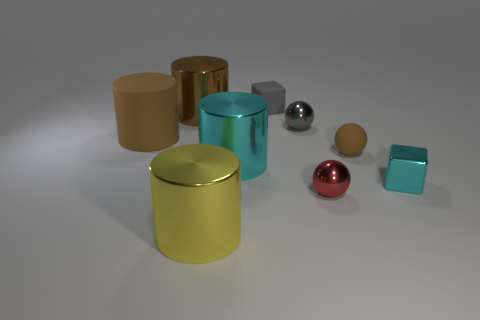What number of metal objects are either tiny purple cubes or large objects?
Ensure brevity in your answer.  3. Is the number of large yellow things behind the gray matte object greater than the number of tiny cyan things that are right of the small cyan thing?
Your answer should be very brief. No. What number of other things are there of the same size as the gray matte cube?
Make the answer very short. 4. What size is the cyan metallic object that is to the left of the gray thing that is right of the small matte block?
Provide a succinct answer. Large. How many tiny objects are either brown balls or cyan shiny cylinders?
Give a very brief answer. 1. There is a brown thing that is in front of the big brown cylinder that is in front of the big metallic cylinder behind the small rubber ball; how big is it?
Offer a very short reply. Small. Is there any other thing of the same color as the big rubber thing?
Provide a succinct answer. Yes. There is a small brown ball right of the gray thing that is behind the big shiny thing behind the brown sphere; what is it made of?
Give a very brief answer. Rubber. Does the small brown rubber object have the same shape as the large yellow object?
Provide a succinct answer. No. Is there anything else that has the same material as the tiny red thing?
Keep it short and to the point. Yes. 